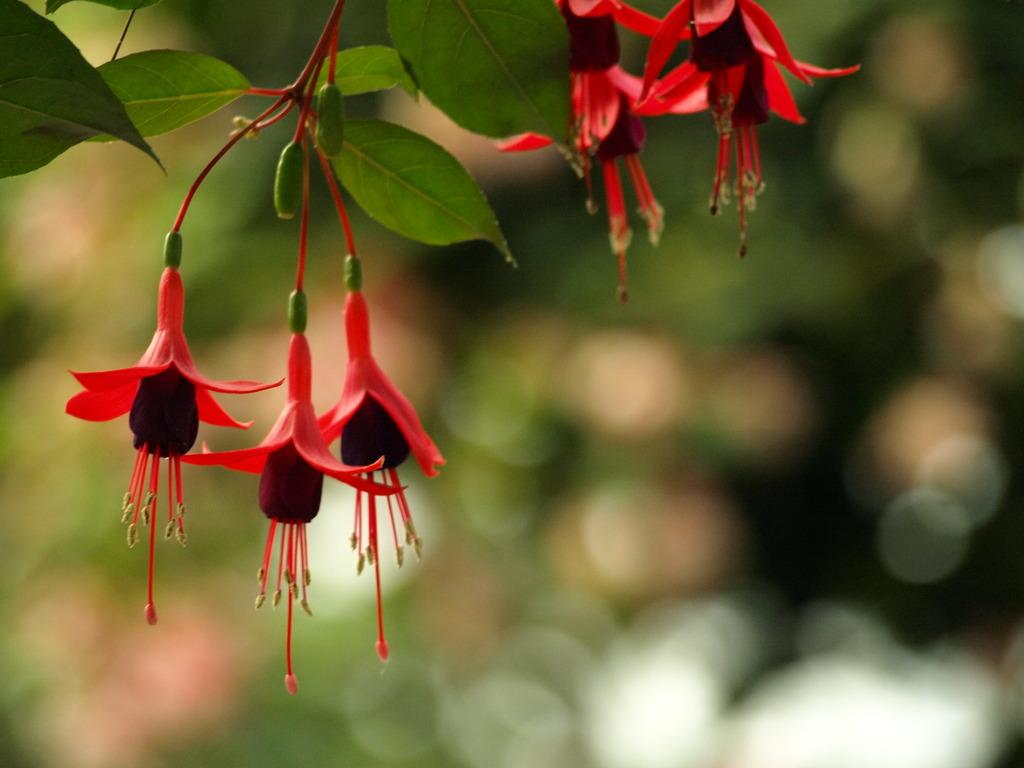What is the main subject of the image? There is a plant in the image. How is the plant depicted in the image? The plant is truncated towards the top of the image. Are there any specific features of the plant? Yes, there are flowers on the plant. Can you describe the background of the image? The background of the image is blurred. How does the baby stretch on the road in the image? There is no baby or road present in the image; it features a plant with flowers and a blurred background. 